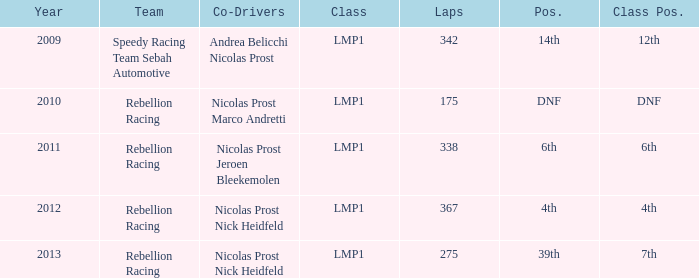What was the class position of the team that was in the 4th position? 4th. 